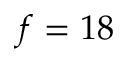Convert formula to latex. <formula><loc_0><loc_0><loc_500><loc_500>f = 1 8</formula> 